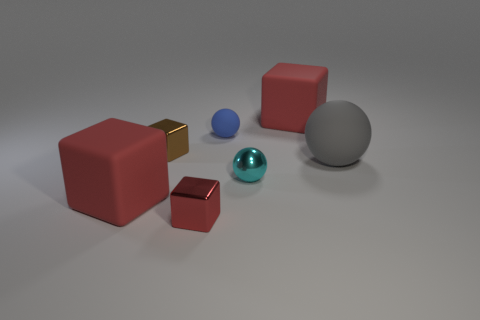Subtract all yellow balls. How many red blocks are left? 3 Subtract 1 blocks. How many blocks are left? 3 Add 3 cyan matte cylinders. How many objects exist? 10 Subtract all spheres. How many objects are left? 4 Subtract 0 green cylinders. How many objects are left? 7 Subtract all tiny green shiny things. Subtract all small cyan balls. How many objects are left? 6 Add 1 cyan metallic objects. How many cyan metallic objects are left? 2 Add 6 big objects. How many big objects exist? 9 